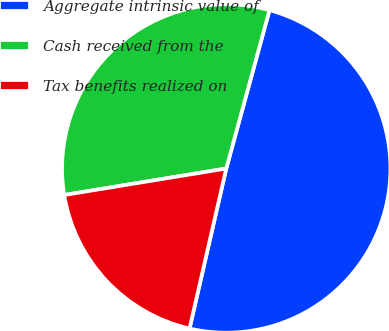<chart> <loc_0><loc_0><loc_500><loc_500><pie_chart><fcel>Aggregate intrinsic value of<fcel>Cash received from the<fcel>Tax benefits realized on<nl><fcel>49.35%<fcel>31.82%<fcel>18.83%<nl></chart> 